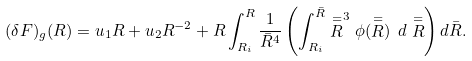Convert formula to latex. <formula><loc_0><loc_0><loc_500><loc_500>( \delta F ) _ { g } ( R ) = u _ { 1 } R + u _ { 2 } R ^ { - 2 } + R \int _ { R _ { i } } ^ { R } \frac { 1 } { \bar { R } ^ { 4 } } \left ( \int _ { R _ { i } } ^ { \bar { R } } \stackrel { = } { R } ^ { 3 } \phi ( \stackrel { = } { R } ) \ d \stackrel { = } { R } \right ) d \bar { R } .</formula> 